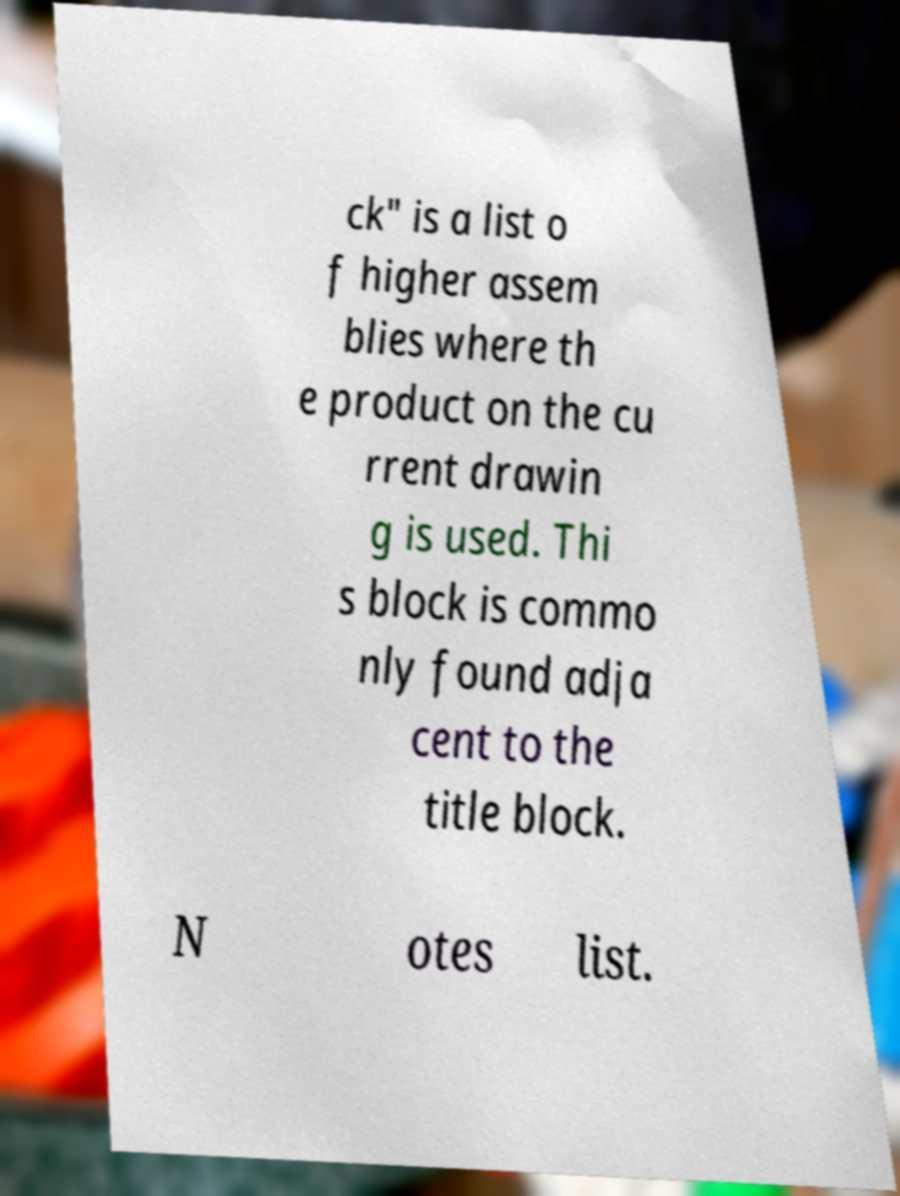Could you extract and type out the text from this image? ck" is a list o f higher assem blies where th e product on the cu rrent drawin g is used. Thi s block is commo nly found adja cent to the title block. N otes list. 